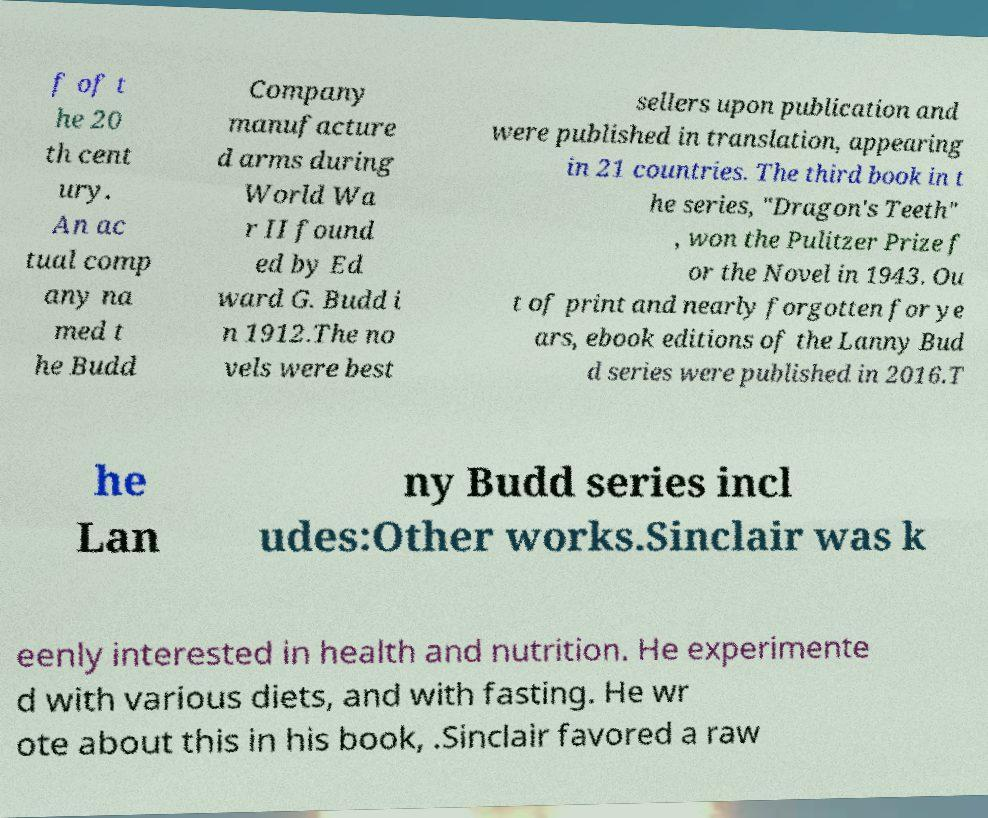I need the written content from this picture converted into text. Can you do that? f of t he 20 th cent ury. An ac tual comp any na med t he Budd Company manufacture d arms during World Wa r II found ed by Ed ward G. Budd i n 1912.The no vels were best sellers upon publication and were published in translation, appearing in 21 countries. The third book in t he series, "Dragon's Teeth" , won the Pulitzer Prize f or the Novel in 1943. Ou t of print and nearly forgotten for ye ars, ebook editions of the Lanny Bud d series were published in 2016.T he Lan ny Budd series incl udes:Other works.Sinclair was k eenly interested in health and nutrition. He experimente d with various diets, and with fasting. He wr ote about this in his book, .Sinclair favored a raw 